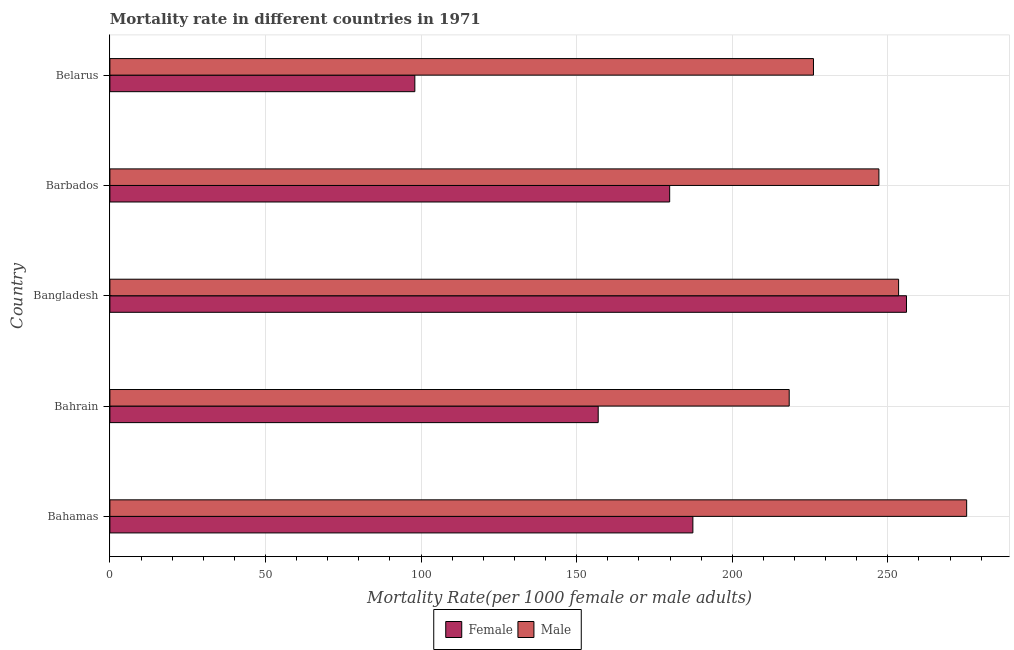How many different coloured bars are there?
Your answer should be compact. 2. How many groups of bars are there?
Ensure brevity in your answer.  5. Are the number of bars per tick equal to the number of legend labels?
Offer a very short reply. Yes. Are the number of bars on each tick of the Y-axis equal?
Your answer should be compact. Yes. How many bars are there on the 1st tick from the top?
Offer a very short reply. 2. What is the label of the 5th group of bars from the top?
Your answer should be compact. Bahamas. In how many cases, is the number of bars for a given country not equal to the number of legend labels?
Offer a very short reply. 0. What is the female mortality rate in Bahrain?
Offer a terse response. 156.93. Across all countries, what is the maximum female mortality rate?
Your answer should be very brief. 255.99. Across all countries, what is the minimum male mortality rate?
Offer a terse response. 218.31. In which country was the female mortality rate minimum?
Ensure brevity in your answer.  Belarus. What is the total male mortality rate in the graph?
Offer a very short reply. 1220.34. What is the difference between the male mortality rate in Bahamas and that in Barbados?
Provide a short and direct response. 28.2. What is the difference between the male mortality rate in Bahamas and the female mortality rate in Barbados?
Provide a short and direct response. 95.44. What is the average female mortality rate per country?
Keep it short and to the point. 175.63. What is the difference between the male mortality rate and female mortality rate in Bangladesh?
Make the answer very short. -2.54. What is the ratio of the male mortality rate in Bahamas to that in Belarus?
Your answer should be compact. 1.22. Is the male mortality rate in Bahrain less than that in Barbados?
Provide a succinct answer. Yes. What is the difference between the highest and the second highest female mortality rate?
Your answer should be very brief. 68.64. What is the difference between the highest and the lowest female mortality rate?
Provide a succinct answer. 157.99. In how many countries, is the female mortality rate greater than the average female mortality rate taken over all countries?
Provide a short and direct response. 3. Is the sum of the male mortality rate in Bahamas and Barbados greater than the maximum female mortality rate across all countries?
Provide a short and direct response. Yes. Are all the bars in the graph horizontal?
Keep it short and to the point. Yes. Does the graph contain any zero values?
Give a very brief answer. No. Does the graph contain grids?
Make the answer very short. Yes. Where does the legend appear in the graph?
Your response must be concise. Bottom center. What is the title of the graph?
Offer a very short reply. Mortality rate in different countries in 1971. What is the label or title of the X-axis?
Offer a terse response. Mortality Rate(per 1000 female or male adults). What is the label or title of the Y-axis?
Your answer should be compact. Country. What is the Mortality Rate(per 1000 female or male adults) in Female in Bahamas?
Your response must be concise. 187.35. What is the Mortality Rate(per 1000 female or male adults) of Male in Bahamas?
Provide a short and direct response. 275.33. What is the Mortality Rate(per 1000 female or male adults) of Female in Bahrain?
Offer a terse response. 156.93. What is the Mortality Rate(per 1000 female or male adults) of Male in Bahrain?
Provide a succinct answer. 218.31. What is the Mortality Rate(per 1000 female or male adults) of Female in Bangladesh?
Give a very brief answer. 255.99. What is the Mortality Rate(per 1000 female or male adults) in Male in Bangladesh?
Offer a very short reply. 253.46. What is the Mortality Rate(per 1000 female or male adults) in Female in Barbados?
Ensure brevity in your answer.  179.89. What is the Mortality Rate(per 1000 female or male adults) in Male in Barbados?
Provide a succinct answer. 247.13. What is the Mortality Rate(per 1000 female or male adults) in Female in Belarus?
Ensure brevity in your answer.  98. What is the Mortality Rate(per 1000 female or male adults) of Male in Belarus?
Offer a terse response. 226.11. Across all countries, what is the maximum Mortality Rate(per 1000 female or male adults) in Female?
Give a very brief answer. 255.99. Across all countries, what is the maximum Mortality Rate(per 1000 female or male adults) in Male?
Your response must be concise. 275.33. Across all countries, what is the minimum Mortality Rate(per 1000 female or male adults) of Female?
Offer a very short reply. 98. Across all countries, what is the minimum Mortality Rate(per 1000 female or male adults) of Male?
Your response must be concise. 218.31. What is the total Mortality Rate(per 1000 female or male adults) in Female in the graph?
Provide a succinct answer. 878.16. What is the total Mortality Rate(per 1000 female or male adults) in Male in the graph?
Provide a short and direct response. 1220.34. What is the difference between the Mortality Rate(per 1000 female or male adults) in Female in Bahamas and that in Bahrain?
Your response must be concise. 30.42. What is the difference between the Mortality Rate(per 1000 female or male adults) of Male in Bahamas and that in Bahrain?
Provide a short and direct response. 57.02. What is the difference between the Mortality Rate(per 1000 female or male adults) in Female in Bahamas and that in Bangladesh?
Your answer should be very brief. -68.64. What is the difference between the Mortality Rate(per 1000 female or male adults) of Male in Bahamas and that in Bangladesh?
Your response must be concise. 21.87. What is the difference between the Mortality Rate(per 1000 female or male adults) in Female in Bahamas and that in Barbados?
Provide a short and direct response. 7.46. What is the difference between the Mortality Rate(per 1000 female or male adults) of Male in Bahamas and that in Barbados?
Make the answer very short. 28.2. What is the difference between the Mortality Rate(per 1000 female or male adults) of Female in Bahamas and that in Belarus?
Your answer should be very brief. 89.35. What is the difference between the Mortality Rate(per 1000 female or male adults) in Male in Bahamas and that in Belarus?
Provide a short and direct response. 49.23. What is the difference between the Mortality Rate(per 1000 female or male adults) in Female in Bahrain and that in Bangladesh?
Keep it short and to the point. -99.07. What is the difference between the Mortality Rate(per 1000 female or male adults) in Male in Bahrain and that in Bangladesh?
Give a very brief answer. -35.15. What is the difference between the Mortality Rate(per 1000 female or male adults) of Female in Bahrain and that in Barbados?
Keep it short and to the point. -22.97. What is the difference between the Mortality Rate(per 1000 female or male adults) in Male in Bahrain and that in Barbados?
Ensure brevity in your answer.  -28.82. What is the difference between the Mortality Rate(per 1000 female or male adults) of Female in Bahrain and that in Belarus?
Your response must be concise. 58.92. What is the difference between the Mortality Rate(per 1000 female or male adults) in Male in Bahrain and that in Belarus?
Offer a terse response. -7.8. What is the difference between the Mortality Rate(per 1000 female or male adults) of Female in Bangladesh and that in Barbados?
Your answer should be very brief. 76.1. What is the difference between the Mortality Rate(per 1000 female or male adults) in Male in Bangladesh and that in Barbados?
Ensure brevity in your answer.  6.33. What is the difference between the Mortality Rate(per 1000 female or male adults) of Female in Bangladesh and that in Belarus?
Keep it short and to the point. 157.99. What is the difference between the Mortality Rate(per 1000 female or male adults) in Male in Bangladesh and that in Belarus?
Your answer should be compact. 27.35. What is the difference between the Mortality Rate(per 1000 female or male adults) of Female in Barbados and that in Belarus?
Keep it short and to the point. 81.89. What is the difference between the Mortality Rate(per 1000 female or male adults) of Male in Barbados and that in Belarus?
Give a very brief answer. 21.02. What is the difference between the Mortality Rate(per 1000 female or male adults) of Female in Bahamas and the Mortality Rate(per 1000 female or male adults) of Male in Bahrain?
Ensure brevity in your answer.  -30.96. What is the difference between the Mortality Rate(per 1000 female or male adults) of Female in Bahamas and the Mortality Rate(per 1000 female or male adults) of Male in Bangladesh?
Your response must be concise. -66.11. What is the difference between the Mortality Rate(per 1000 female or male adults) in Female in Bahamas and the Mortality Rate(per 1000 female or male adults) in Male in Barbados?
Offer a very short reply. -59.78. What is the difference between the Mortality Rate(per 1000 female or male adults) in Female in Bahamas and the Mortality Rate(per 1000 female or male adults) in Male in Belarus?
Ensure brevity in your answer.  -38.76. What is the difference between the Mortality Rate(per 1000 female or male adults) in Female in Bahrain and the Mortality Rate(per 1000 female or male adults) in Male in Bangladesh?
Your answer should be compact. -96.53. What is the difference between the Mortality Rate(per 1000 female or male adults) of Female in Bahrain and the Mortality Rate(per 1000 female or male adults) of Male in Barbados?
Offer a very short reply. -90.2. What is the difference between the Mortality Rate(per 1000 female or male adults) in Female in Bahrain and the Mortality Rate(per 1000 female or male adults) in Male in Belarus?
Provide a short and direct response. -69.18. What is the difference between the Mortality Rate(per 1000 female or male adults) in Female in Bangladesh and the Mortality Rate(per 1000 female or male adults) in Male in Barbados?
Ensure brevity in your answer.  8.86. What is the difference between the Mortality Rate(per 1000 female or male adults) of Female in Bangladesh and the Mortality Rate(per 1000 female or male adults) of Male in Belarus?
Your response must be concise. 29.89. What is the difference between the Mortality Rate(per 1000 female or male adults) in Female in Barbados and the Mortality Rate(per 1000 female or male adults) in Male in Belarus?
Offer a very short reply. -46.21. What is the average Mortality Rate(per 1000 female or male adults) of Female per country?
Your answer should be very brief. 175.63. What is the average Mortality Rate(per 1000 female or male adults) of Male per country?
Give a very brief answer. 244.07. What is the difference between the Mortality Rate(per 1000 female or male adults) in Female and Mortality Rate(per 1000 female or male adults) in Male in Bahamas?
Give a very brief answer. -87.98. What is the difference between the Mortality Rate(per 1000 female or male adults) in Female and Mortality Rate(per 1000 female or male adults) in Male in Bahrain?
Offer a terse response. -61.38. What is the difference between the Mortality Rate(per 1000 female or male adults) in Female and Mortality Rate(per 1000 female or male adults) in Male in Bangladesh?
Keep it short and to the point. 2.54. What is the difference between the Mortality Rate(per 1000 female or male adults) of Female and Mortality Rate(per 1000 female or male adults) of Male in Barbados?
Give a very brief answer. -67.24. What is the difference between the Mortality Rate(per 1000 female or male adults) of Female and Mortality Rate(per 1000 female or male adults) of Male in Belarus?
Give a very brief answer. -128.1. What is the ratio of the Mortality Rate(per 1000 female or male adults) in Female in Bahamas to that in Bahrain?
Offer a very short reply. 1.19. What is the ratio of the Mortality Rate(per 1000 female or male adults) in Male in Bahamas to that in Bahrain?
Provide a succinct answer. 1.26. What is the ratio of the Mortality Rate(per 1000 female or male adults) of Female in Bahamas to that in Bangladesh?
Offer a very short reply. 0.73. What is the ratio of the Mortality Rate(per 1000 female or male adults) in Male in Bahamas to that in Bangladesh?
Provide a succinct answer. 1.09. What is the ratio of the Mortality Rate(per 1000 female or male adults) in Female in Bahamas to that in Barbados?
Make the answer very short. 1.04. What is the ratio of the Mortality Rate(per 1000 female or male adults) of Male in Bahamas to that in Barbados?
Offer a terse response. 1.11. What is the ratio of the Mortality Rate(per 1000 female or male adults) of Female in Bahamas to that in Belarus?
Ensure brevity in your answer.  1.91. What is the ratio of the Mortality Rate(per 1000 female or male adults) of Male in Bahamas to that in Belarus?
Offer a very short reply. 1.22. What is the ratio of the Mortality Rate(per 1000 female or male adults) in Female in Bahrain to that in Bangladesh?
Offer a terse response. 0.61. What is the ratio of the Mortality Rate(per 1000 female or male adults) in Male in Bahrain to that in Bangladesh?
Give a very brief answer. 0.86. What is the ratio of the Mortality Rate(per 1000 female or male adults) in Female in Bahrain to that in Barbados?
Keep it short and to the point. 0.87. What is the ratio of the Mortality Rate(per 1000 female or male adults) of Male in Bahrain to that in Barbados?
Give a very brief answer. 0.88. What is the ratio of the Mortality Rate(per 1000 female or male adults) of Female in Bahrain to that in Belarus?
Provide a succinct answer. 1.6. What is the ratio of the Mortality Rate(per 1000 female or male adults) of Male in Bahrain to that in Belarus?
Make the answer very short. 0.97. What is the ratio of the Mortality Rate(per 1000 female or male adults) in Female in Bangladesh to that in Barbados?
Offer a very short reply. 1.42. What is the ratio of the Mortality Rate(per 1000 female or male adults) in Male in Bangladesh to that in Barbados?
Keep it short and to the point. 1.03. What is the ratio of the Mortality Rate(per 1000 female or male adults) in Female in Bangladesh to that in Belarus?
Make the answer very short. 2.61. What is the ratio of the Mortality Rate(per 1000 female or male adults) of Male in Bangladesh to that in Belarus?
Your answer should be compact. 1.12. What is the ratio of the Mortality Rate(per 1000 female or male adults) in Female in Barbados to that in Belarus?
Ensure brevity in your answer.  1.84. What is the ratio of the Mortality Rate(per 1000 female or male adults) of Male in Barbados to that in Belarus?
Your answer should be compact. 1.09. What is the difference between the highest and the second highest Mortality Rate(per 1000 female or male adults) of Female?
Give a very brief answer. 68.64. What is the difference between the highest and the second highest Mortality Rate(per 1000 female or male adults) of Male?
Your answer should be very brief. 21.87. What is the difference between the highest and the lowest Mortality Rate(per 1000 female or male adults) of Female?
Make the answer very short. 157.99. What is the difference between the highest and the lowest Mortality Rate(per 1000 female or male adults) of Male?
Your answer should be very brief. 57.02. 